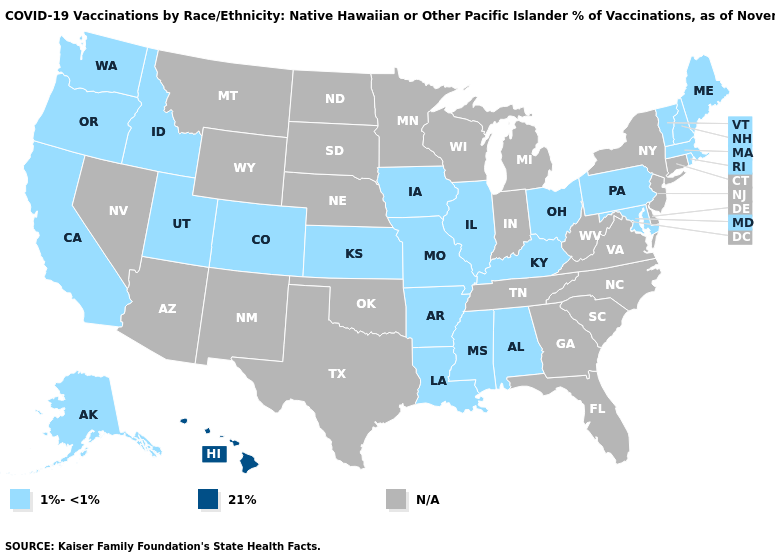What is the highest value in the Northeast ?
Answer briefly. 1%-<1%. Which states have the lowest value in the MidWest?
Be succinct. Illinois, Iowa, Kansas, Missouri, Ohio. Which states have the lowest value in the USA?
Answer briefly. Alabama, Alaska, Arkansas, California, Colorado, Idaho, Illinois, Iowa, Kansas, Kentucky, Louisiana, Maine, Maryland, Massachusetts, Mississippi, Missouri, New Hampshire, Ohio, Oregon, Pennsylvania, Rhode Island, Utah, Vermont, Washington. What is the highest value in states that border Pennsylvania?
Keep it brief. 1%-<1%. Which states have the lowest value in the MidWest?
Answer briefly. Illinois, Iowa, Kansas, Missouri, Ohio. What is the highest value in the USA?
Be succinct. 21%. What is the highest value in the USA?
Quick response, please. 21%. What is the lowest value in the USA?
Short answer required. 1%-<1%. Name the states that have a value in the range 1%-<1%?
Short answer required. Alabama, Alaska, Arkansas, California, Colorado, Idaho, Illinois, Iowa, Kansas, Kentucky, Louisiana, Maine, Maryland, Massachusetts, Mississippi, Missouri, New Hampshire, Ohio, Oregon, Pennsylvania, Rhode Island, Utah, Vermont, Washington. Name the states that have a value in the range 1%-<1%?
Be succinct. Alabama, Alaska, Arkansas, California, Colorado, Idaho, Illinois, Iowa, Kansas, Kentucky, Louisiana, Maine, Maryland, Massachusetts, Mississippi, Missouri, New Hampshire, Ohio, Oregon, Pennsylvania, Rhode Island, Utah, Vermont, Washington. What is the lowest value in the USA?
Write a very short answer. 1%-<1%. What is the value of Texas?
Give a very brief answer. N/A. Does the first symbol in the legend represent the smallest category?
Short answer required. Yes. 